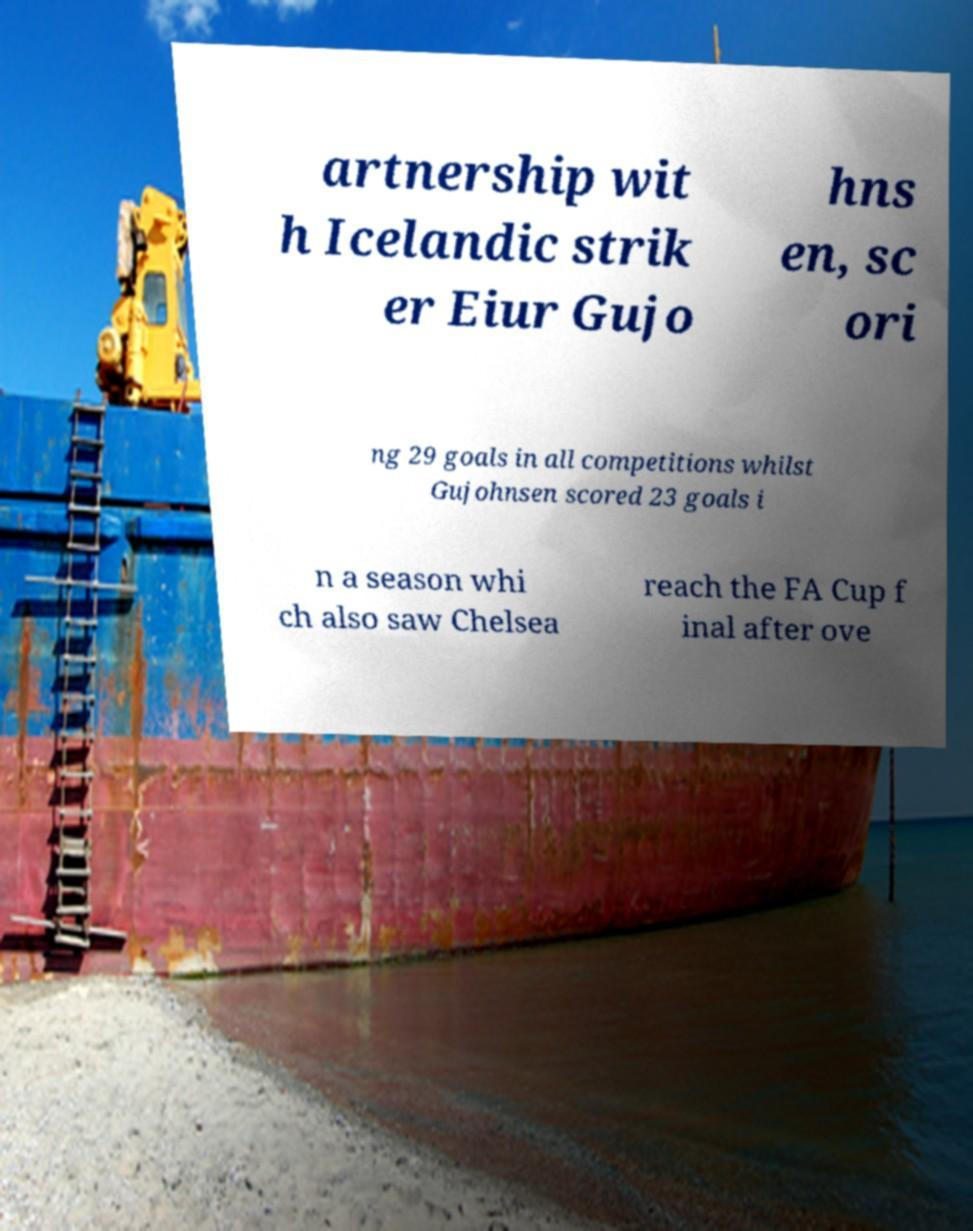Please identify and transcribe the text found in this image. artnership wit h Icelandic strik er Eiur Gujo hns en, sc ori ng 29 goals in all competitions whilst Gujohnsen scored 23 goals i n a season whi ch also saw Chelsea reach the FA Cup f inal after ove 